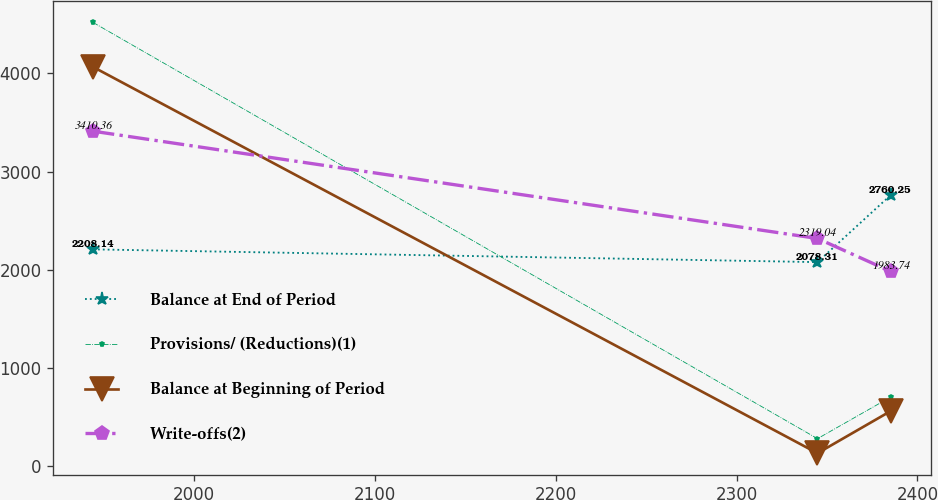Convert chart. <chart><loc_0><loc_0><loc_500><loc_500><line_chart><ecel><fcel>Balance at End of Period<fcel>Provisions/ (Reductions)(1)<fcel>Balance at Beginning of Period<fcel>Write-offs(2)<nl><fcel>1944.38<fcel>2208.14<fcel>4516.36<fcel>4063.8<fcel>3410.36<nl><fcel>2344.73<fcel>2078.31<fcel>282.21<fcel>134.13<fcel>2319.04<nl><fcel>2385.18<fcel>2760.25<fcel>705.62<fcel>563.01<fcel>1983.74<nl></chart> 